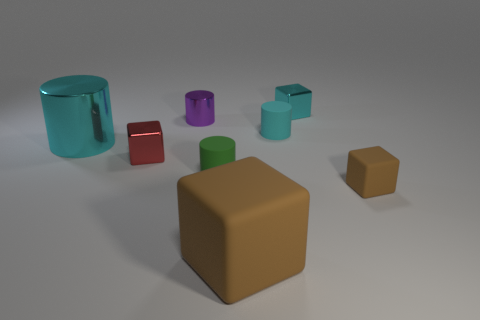Subtract all brown cylinders. Subtract all gray balls. How many cylinders are left? 4 Add 1 tiny shiny things. How many objects exist? 9 Subtract all small brown objects. Subtract all cyan rubber things. How many objects are left? 6 Add 1 cyan shiny blocks. How many cyan shiny blocks are left? 2 Add 7 tiny matte cylinders. How many tiny matte cylinders exist? 9 Subtract 0 purple cubes. How many objects are left? 8 